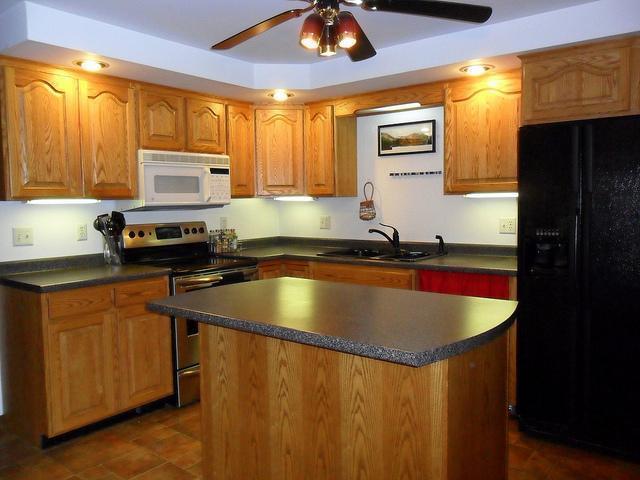What might a person make on the black and silver item on the back left?
Select the accurate response from the four choices given to answer the question.
Options: Jewellery, clothing, food, music. Food. 